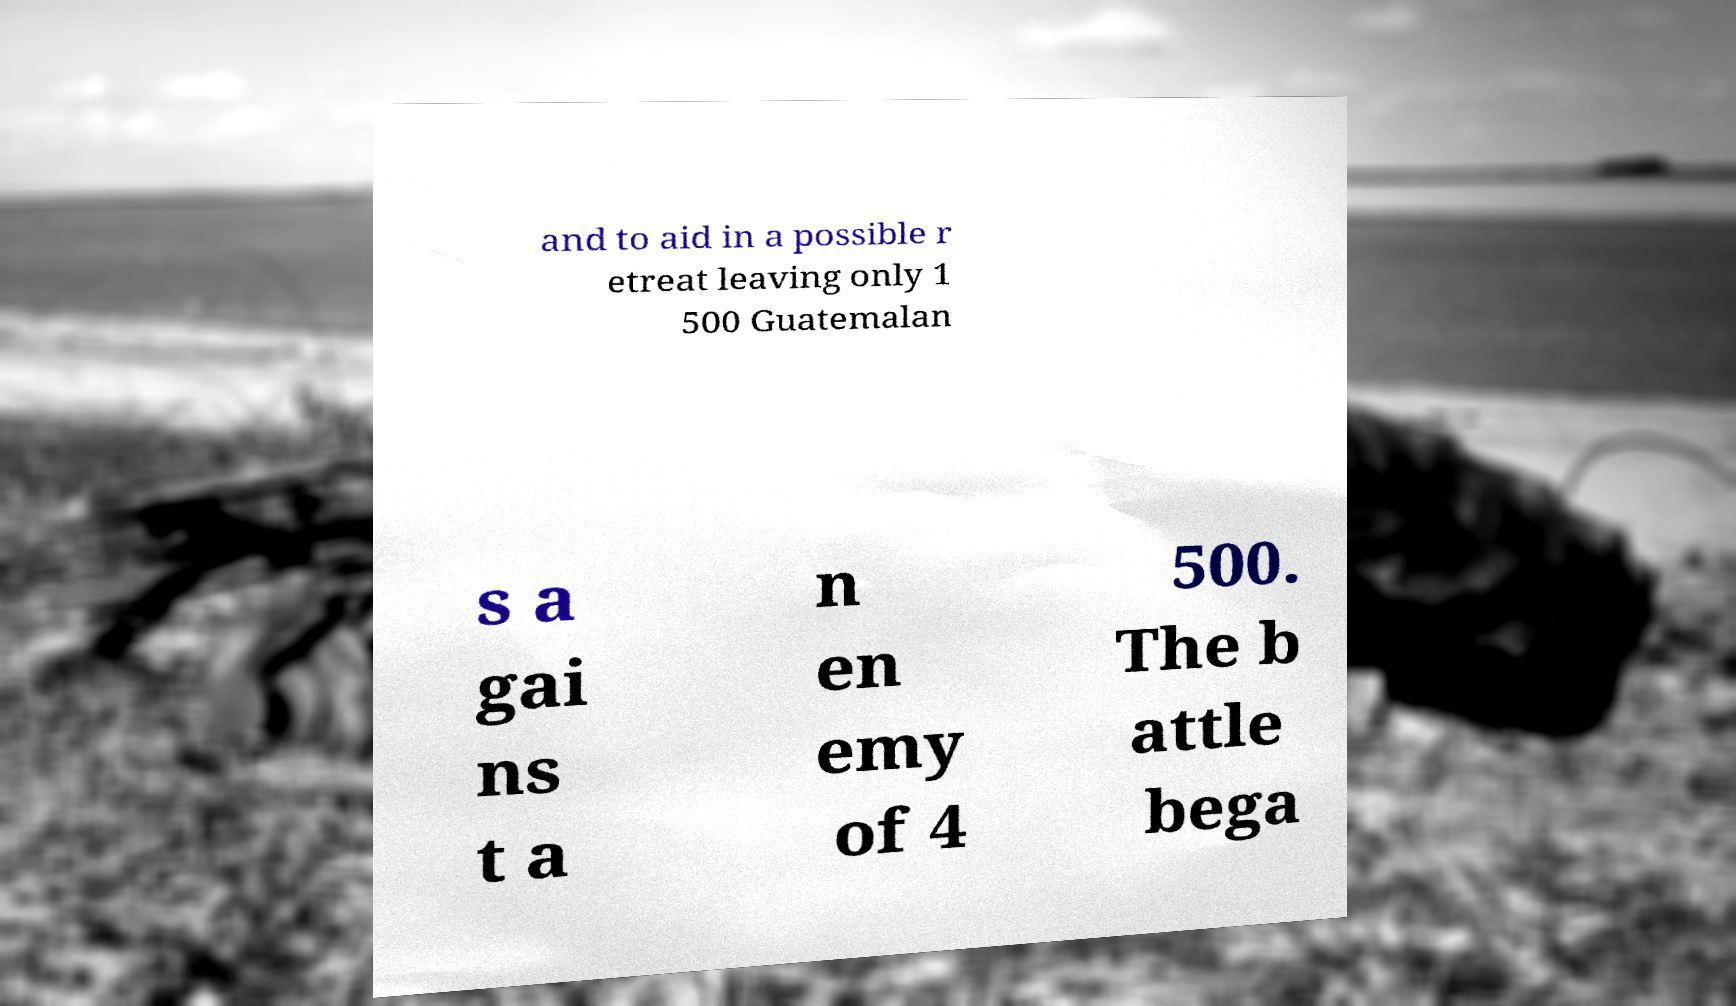Could you extract and type out the text from this image? and to aid in a possible r etreat leaving only 1 500 Guatemalan s a gai ns t a n en emy of 4 500. The b attle bega 